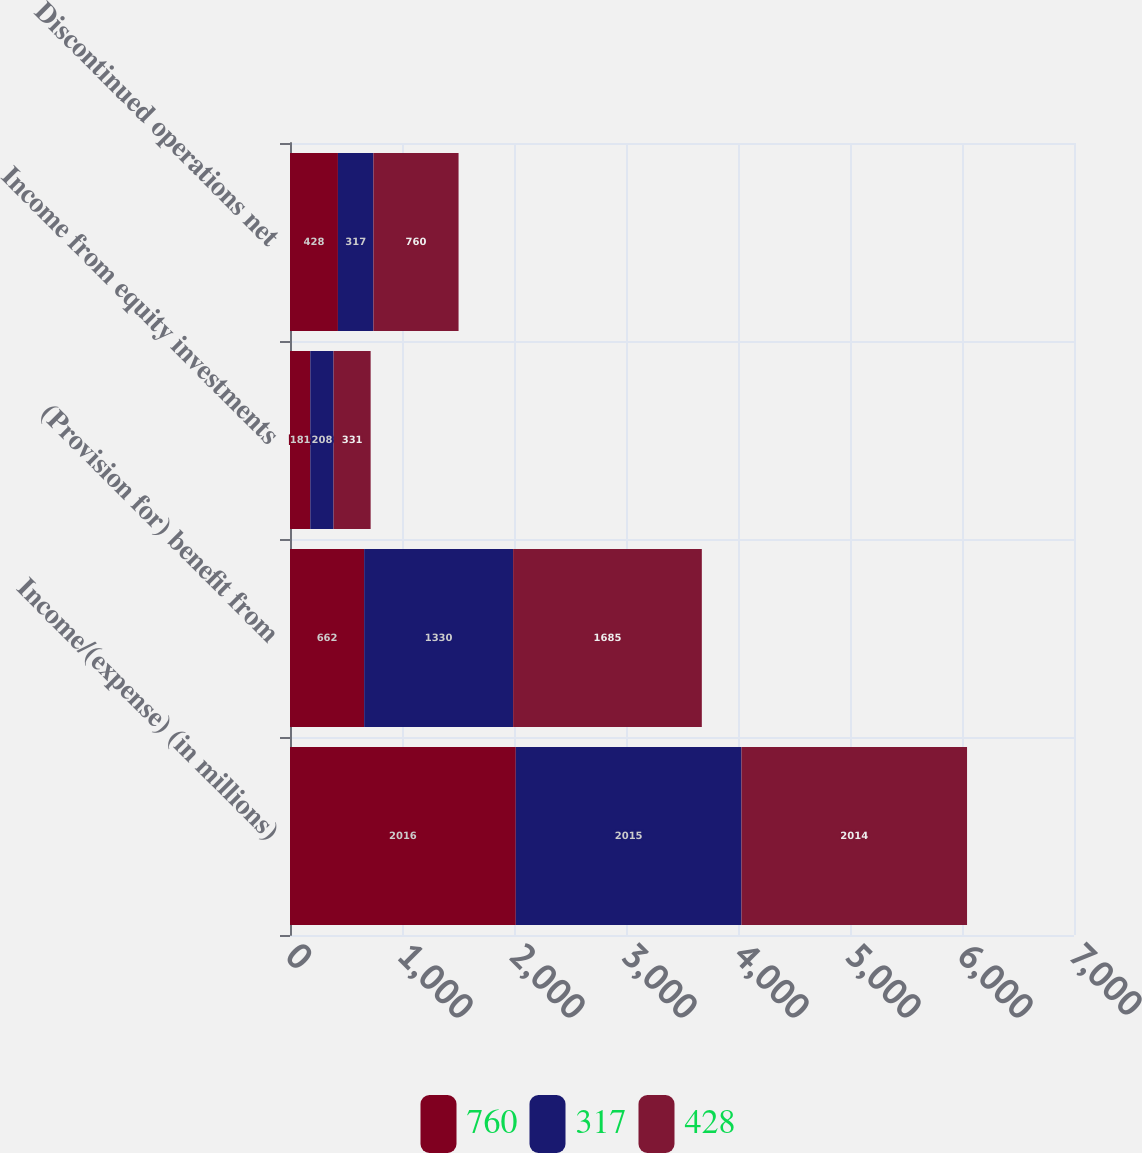<chart> <loc_0><loc_0><loc_500><loc_500><stacked_bar_chart><ecel><fcel>Income/(expense) (in millions)<fcel>(Provision for) benefit from<fcel>Income from equity investments<fcel>Discontinued operations net<nl><fcel>760<fcel>2016<fcel>662<fcel>181<fcel>428<nl><fcel>317<fcel>2015<fcel>1330<fcel>208<fcel>317<nl><fcel>428<fcel>2014<fcel>1685<fcel>331<fcel>760<nl></chart> 